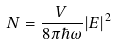<formula> <loc_0><loc_0><loc_500><loc_500>N = \frac { V } { 8 \pi \hbar { \omega } } | E | ^ { 2 }</formula> 